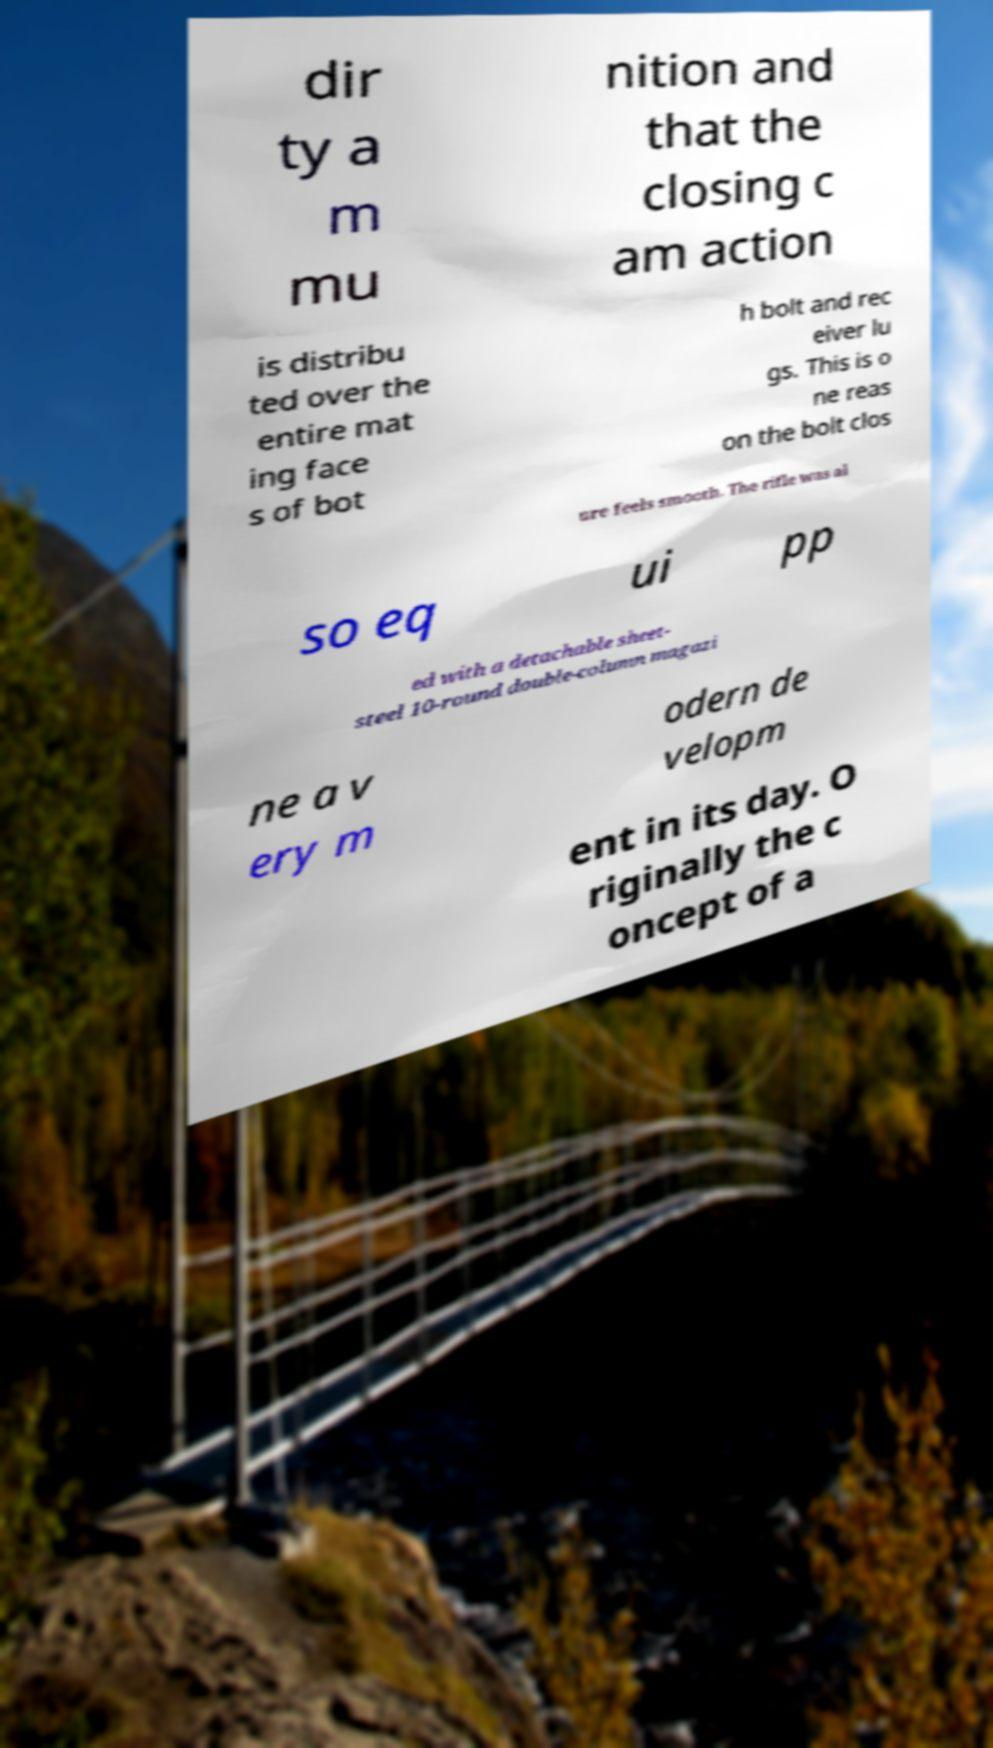Please read and relay the text visible in this image. What does it say? dir ty a m mu nition and that the closing c am action is distribu ted over the entire mat ing face s of bot h bolt and rec eiver lu gs. This is o ne reas on the bolt clos ure feels smooth. The rifle was al so eq ui pp ed with a detachable sheet- steel 10-round double-column magazi ne a v ery m odern de velopm ent in its day. O riginally the c oncept of a 